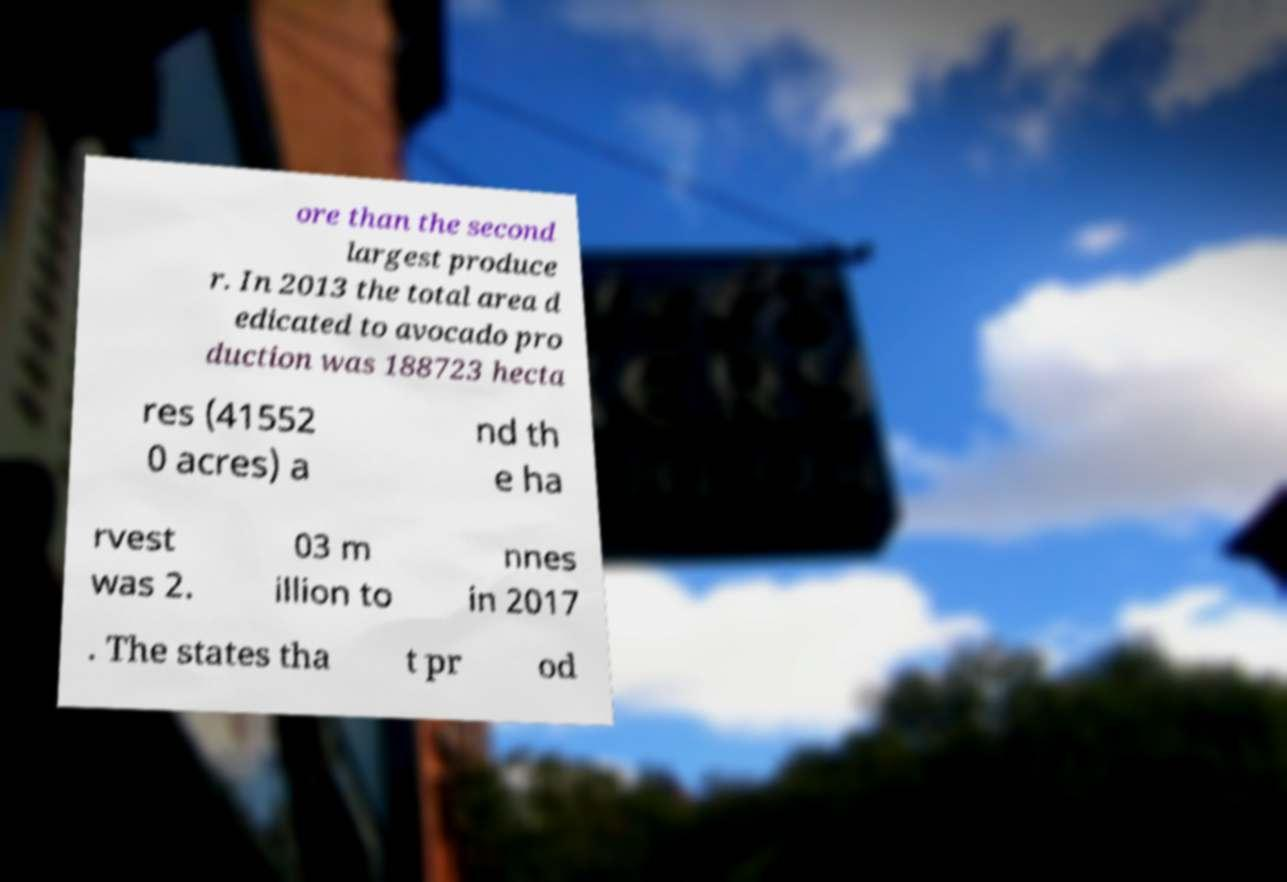I need the written content from this picture converted into text. Can you do that? ore than the second largest produce r. In 2013 the total area d edicated to avocado pro duction was 188723 hecta res (41552 0 acres) a nd th e ha rvest was 2. 03 m illion to nnes in 2017 . The states tha t pr od 